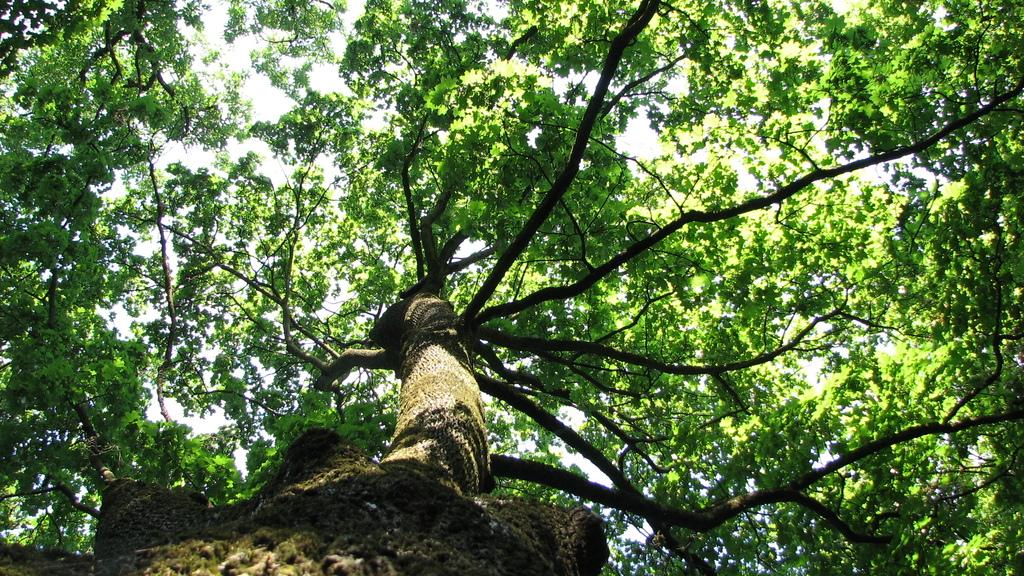What is the main subject of the image? The main subject of the image is a tree trunk. What can be seen at the top of the tree trunk? There are green leaves with stems and branches at the top of the tree trunk. What type of offer is being made by the chickens in the image? There are no chickens present in the image, so no offer can be made by them. 